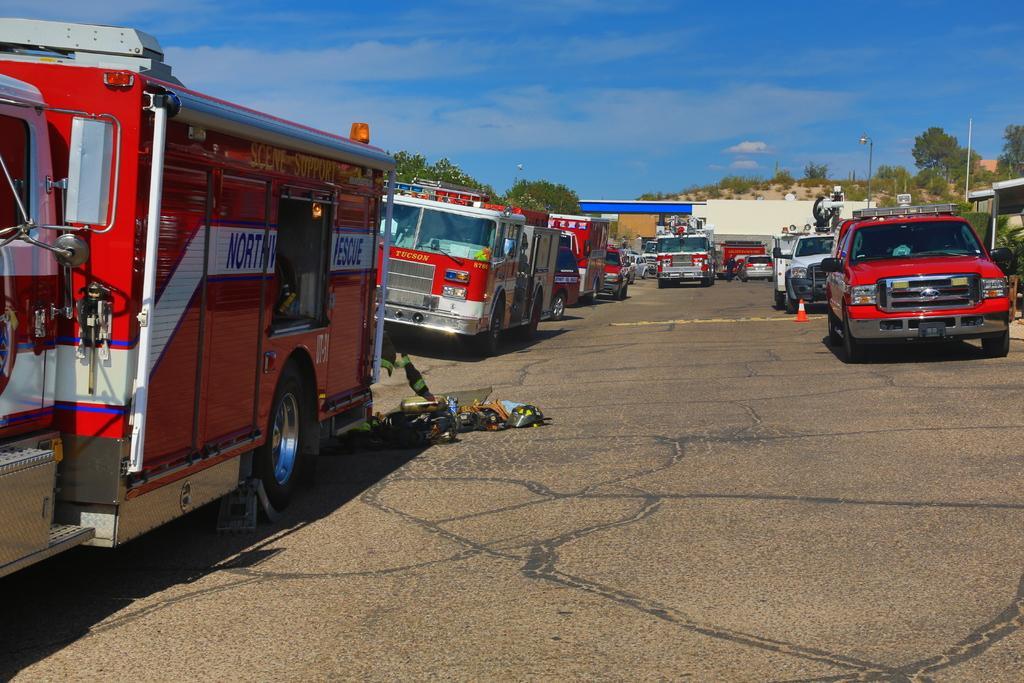Could you give a brief overview of what you see in this image? In this picture we can see few vehicles, in the background we can find few buildings, trees and poles. 